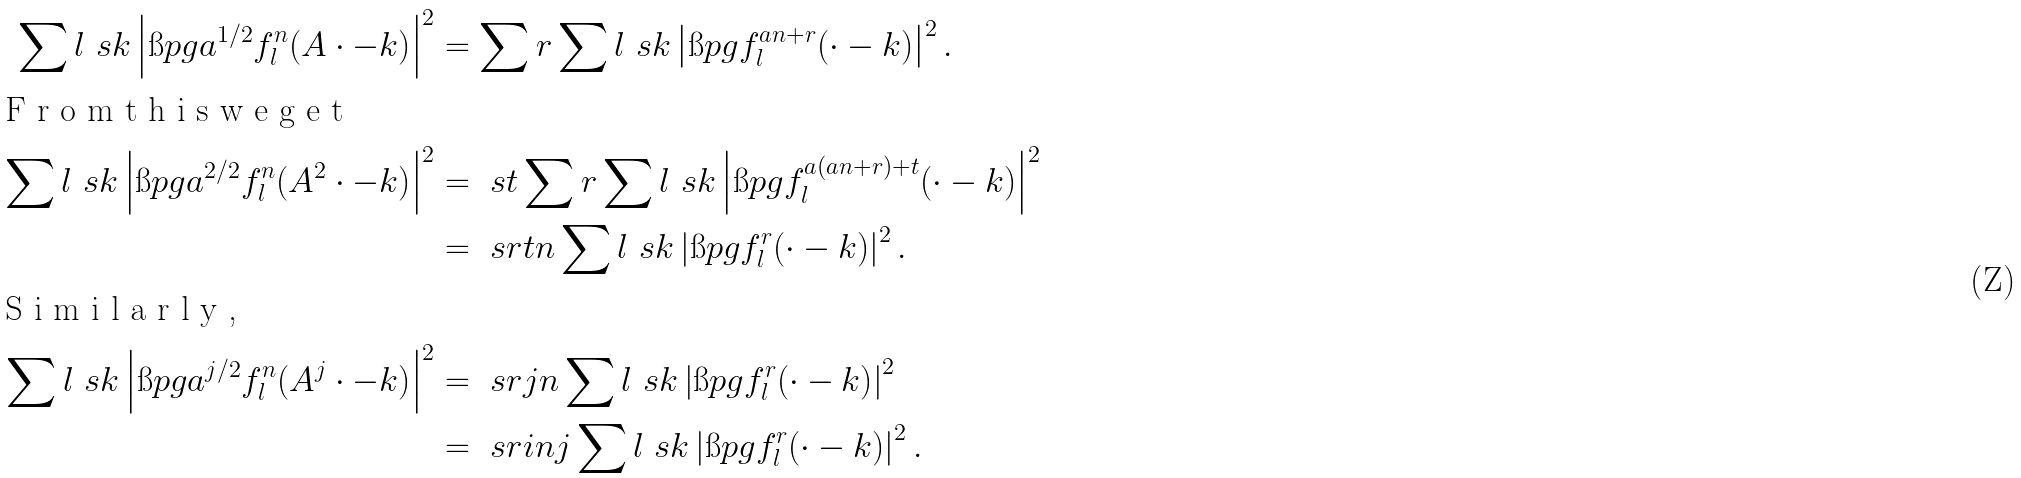<formula> <loc_0><loc_0><loc_500><loc_500>\sum l \ s k \left | \i p { g } { a ^ { 1 / 2 } f ^ { n } _ { l } ( A \cdot - k ) } \right | ^ { 2 } & = \sum r \sum l \ s k \left | \i p { g } { f ^ { a n + r } _ { l } ( \cdot - k ) } \right | ^ { 2 } . \\ \intertext { F r o m t h i s w e g e t } \sum l \ s k \left | \i p { g } { a ^ { 2 / 2 } f ^ { n } _ { l } ( A ^ { 2 } \cdot - k ) } \right | ^ { 2 } & = \ s t \sum r \sum l \ s k \left | \i p { g } { f ^ { a ( a n + r ) + t } _ { l } ( \cdot - k ) } \right | ^ { 2 } \\ & = \ s r t n \sum l \ s k \left | \i p { g } { f ^ { r } _ { l } ( \cdot - k ) } \right | ^ { 2 } . \\ \intertext { S i m i l a r l y , } \sum l \ s k \left | \i p { g } { a ^ { j / 2 } f ^ { n } _ { l } ( A ^ { j } \cdot - k ) } \right | ^ { 2 } & = \ s r j n \sum l \ s k \left | \i p { g } { f ^ { r } _ { l } ( \cdot - k ) } \right | ^ { 2 } \\ & = \ s r i n j \sum l \ s k \left | \i p { g } { f ^ { r } _ { l } ( \cdot - k ) } \right | ^ { 2 } .</formula> 